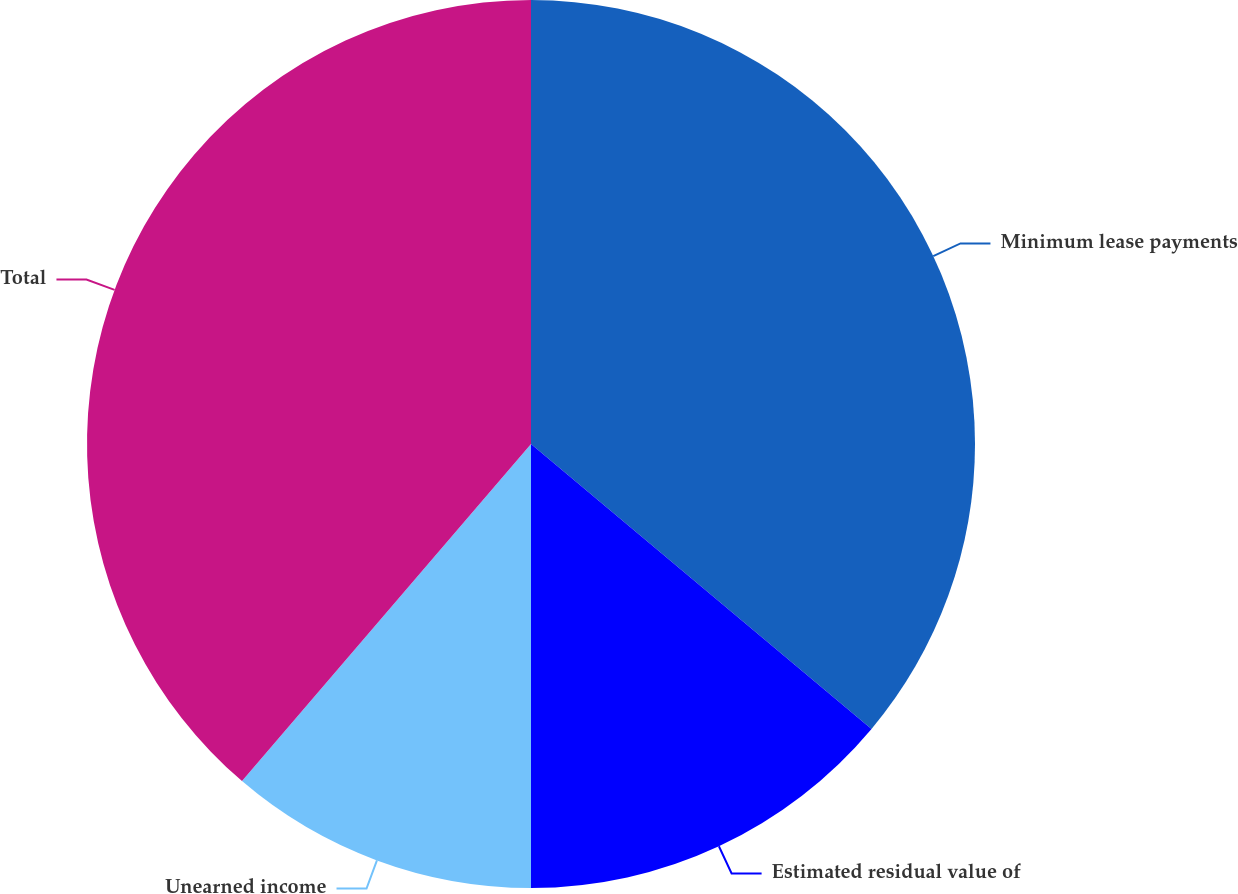Convert chart to OTSL. <chart><loc_0><loc_0><loc_500><loc_500><pie_chart><fcel>Minimum lease payments<fcel>Estimated residual value of<fcel>Unearned income<fcel>Total<nl><fcel>36.09%<fcel>13.91%<fcel>11.28%<fcel>38.72%<nl></chart> 